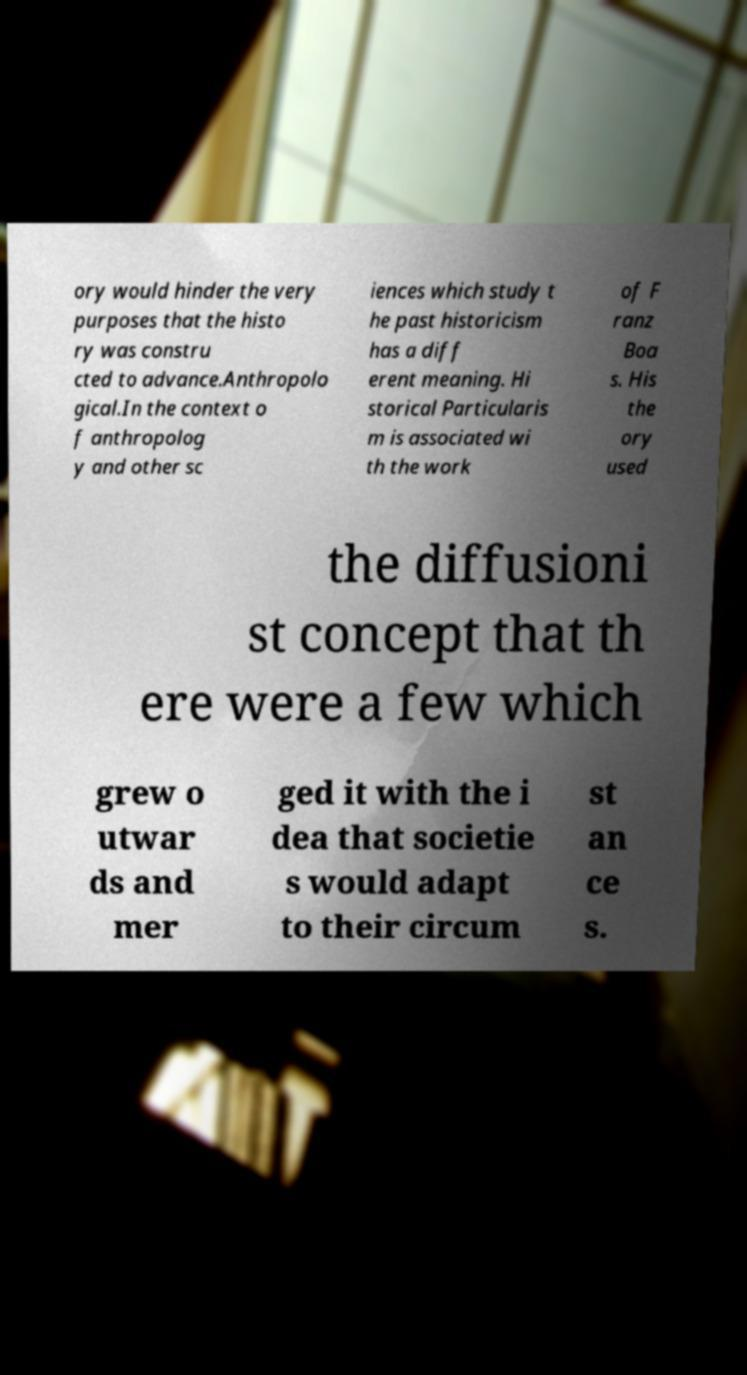Can you accurately transcribe the text from the provided image for me? ory would hinder the very purposes that the histo ry was constru cted to advance.Anthropolo gical.In the context o f anthropolog y and other sc iences which study t he past historicism has a diff erent meaning. Hi storical Particularis m is associated wi th the work of F ranz Boa s. His the ory used the diffusioni st concept that th ere were a few which grew o utwar ds and mer ged it with the i dea that societie s would adapt to their circum st an ce s. 